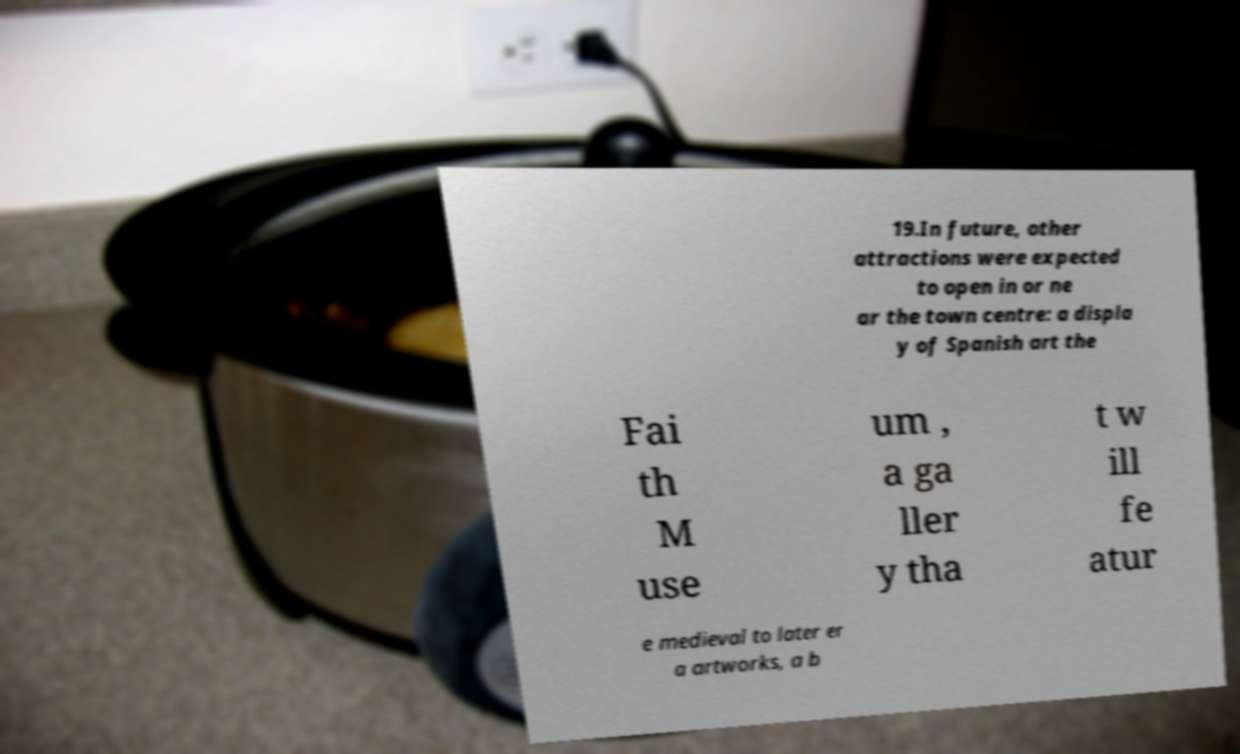Could you assist in decoding the text presented in this image and type it out clearly? 19.In future, other attractions were expected to open in or ne ar the town centre: a displa y of Spanish art the Fai th M use um , a ga ller y tha t w ill fe atur e medieval to later er a artworks, a b 